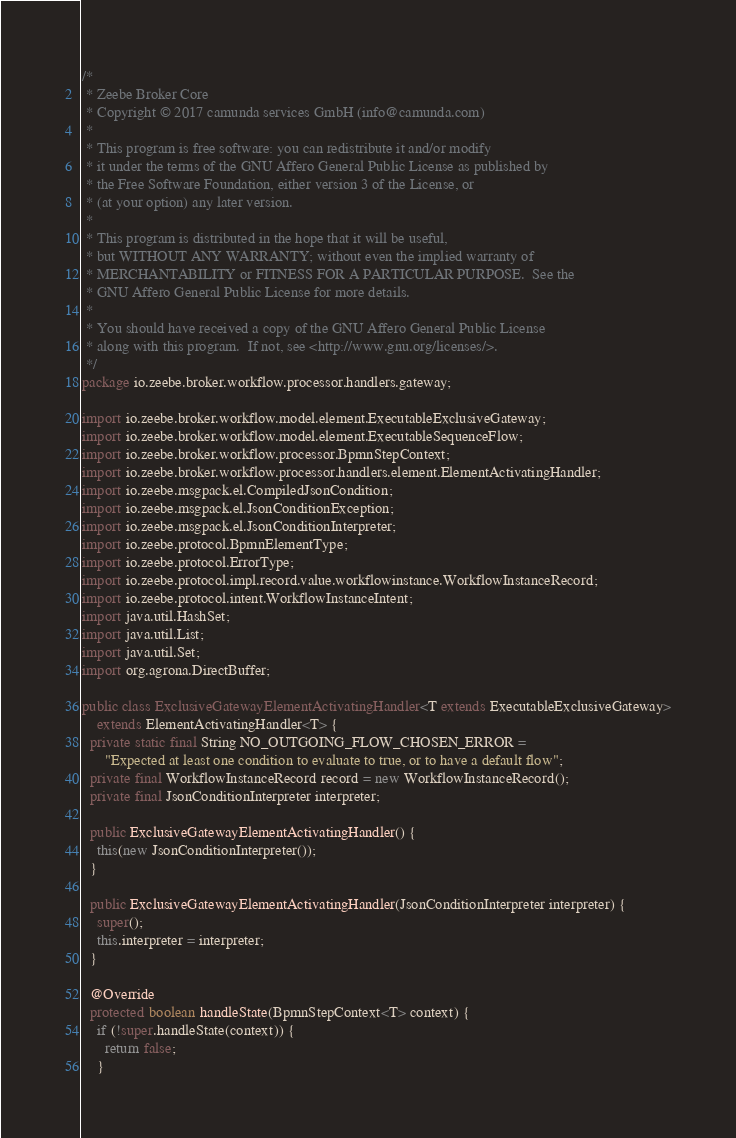<code> <loc_0><loc_0><loc_500><loc_500><_Java_>/*
 * Zeebe Broker Core
 * Copyright © 2017 camunda services GmbH (info@camunda.com)
 *
 * This program is free software: you can redistribute it and/or modify
 * it under the terms of the GNU Affero General Public License as published by
 * the Free Software Foundation, either version 3 of the License, or
 * (at your option) any later version.
 *
 * This program is distributed in the hope that it will be useful,
 * but WITHOUT ANY WARRANTY; without even the implied warranty of
 * MERCHANTABILITY or FITNESS FOR A PARTICULAR PURPOSE.  See the
 * GNU Affero General Public License for more details.
 *
 * You should have received a copy of the GNU Affero General Public License
 * along with this program.  If not, see <http://www.gnu.org/licenses/>.
 */
package io.zeebe.broker.workflow.processor.handlers.gateway;

import io.zeebe.broker.workflow.model.element.ExecutableExclusiveGateway;
import io.zeebe.broker.workflow.model.element.ExecutableSequenceFlow;
import io.zeebe.broker.workflow.processor.BpmnStepContext;
import io.zeebe.broker.workflow.processor.handlers.element.ElementActivatingHandler;
import io.zeebe.msgpack.el.CompiledJsonCondition;
import io.zeebe.msgpack.el.JsonConditionException;
import io.zeebe.msgpack.el.JsonConditionInterpreter;
import io.zeebe.protocol.BpmnElementType;
import io.zeebe.protocol.ErrorType;
import io.zeebe.protocol.impl.record.value.workflowinstance.WorkflowInstanceRecord;
import io.zeebe.protocol.intent.WorkflowInstanceIntent;
import java.util.HashSet;
import java.util.List;
import java.util.Set;
import org.agrona.DirectBuffer;

public class ExclusiveGatewayElementActivatingHandler<T extends ExecutableExclusiveGateway>
    extends ElementActivatingHandler<T> {
  private static final String NO_OUTGOING_FLOW_CHOSEN_ERROR =
      "Expected at least one condition to evaluate to true, or to have a default flow";
  private final WorkflowInstanceRecord record = new WorkflowInstanceRecord();
  private final JsonConditionInterpreter interpreter;

  public ExclusiveGatewayElementActivatingHandler() {
    this(new JsonConditionInterpreter());
  }

  public ExclusiveGatewayElementActivatingHandler(JsonConditionInterpreter interpreter) {
    super();
    this.interpreter = interpreter;
  }

  @Override
  protected boolean handleState(BpmnStepContext<T> context) {
    if (!super.handleState(context)) {
      return false;
    }
</code> 